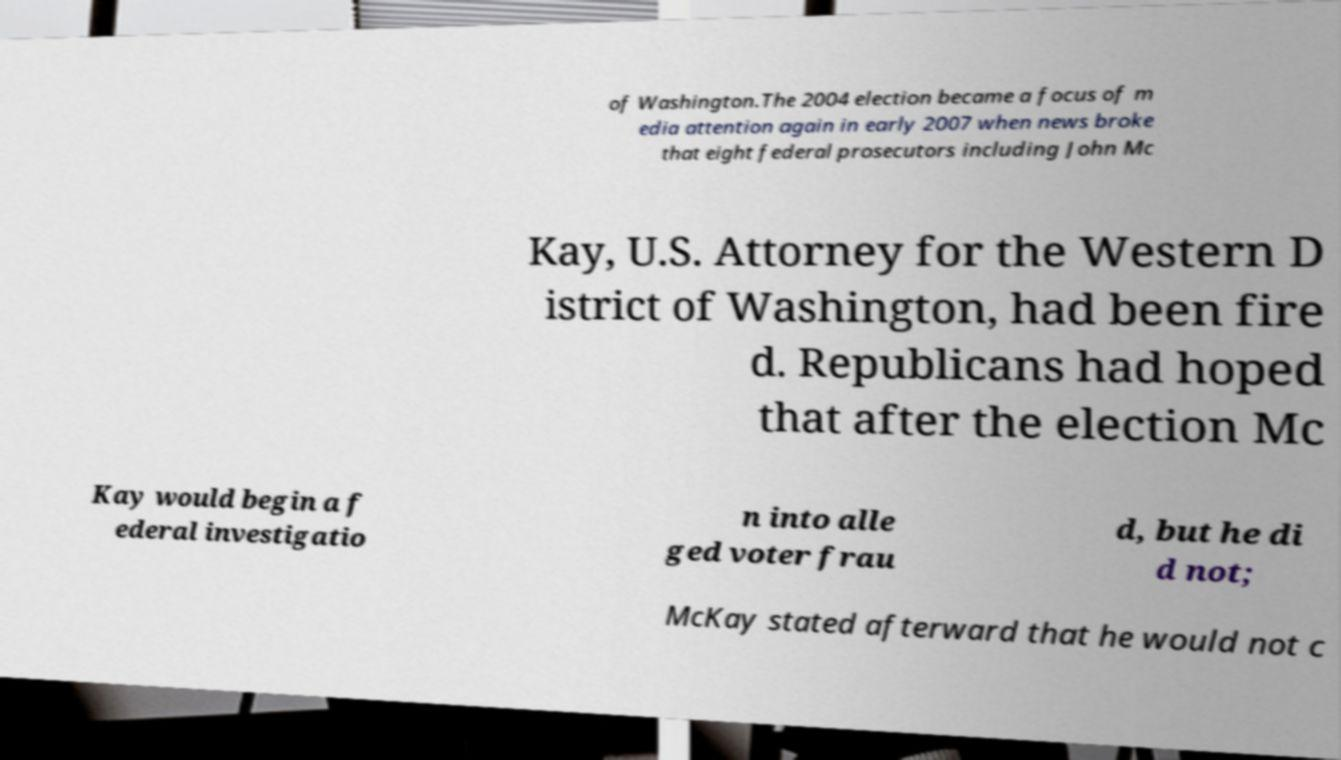Please read and relay the text visible in this image. What does it say? of Washington.The 2004 election became a focus of m edia attention again in early 2007 when news broke that eight federal prosecutors including John Mc Kay, U.S. Attorney for the Western D istrict of Washington, had been fire d. Republicans had hoped that after the election Mc Kay would begin a f ederal investigatio n into alle ged voter frau d, but he di d not; McKay stated afterward that he would not c 